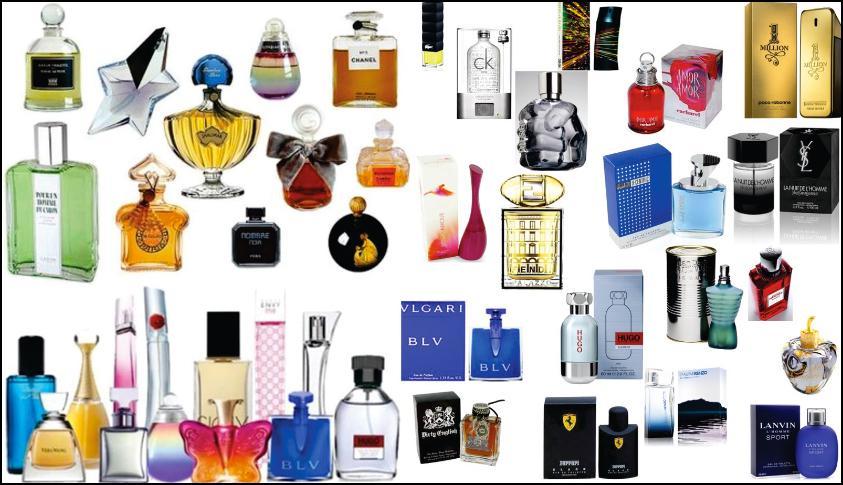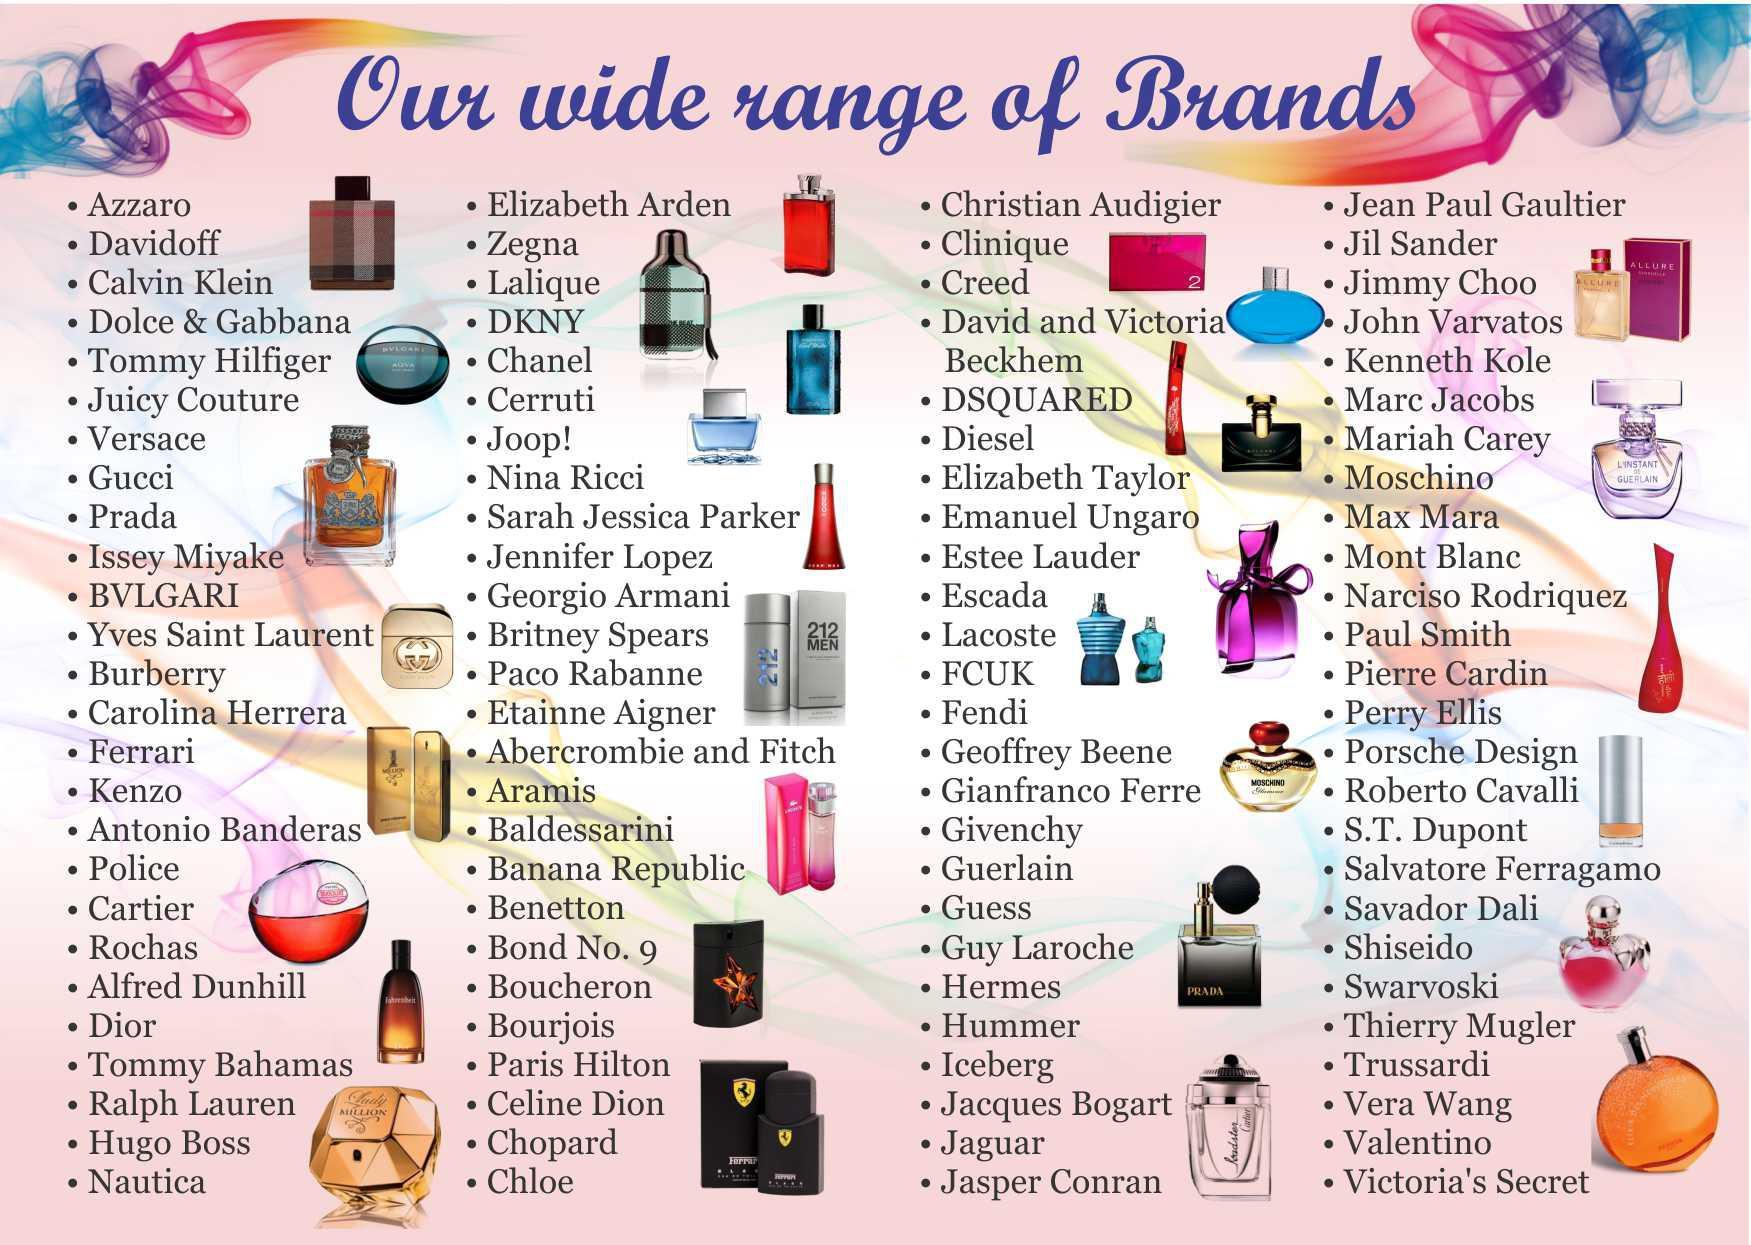The first image is the image on the left, the second image is the image on the right. Given the left and right images, does the statement "One of the images contains a single brand." hold true? Answer yes or no. No. The first image is the image on the left, the second image is the image on the right. Evaluate the accuracy of this statement regarding the images: "Both images show more than a dozen different perfume bottles, with a wide variety of colors, shapes, and sizes represented.". Is it true? Answer yes or no. Yes. 